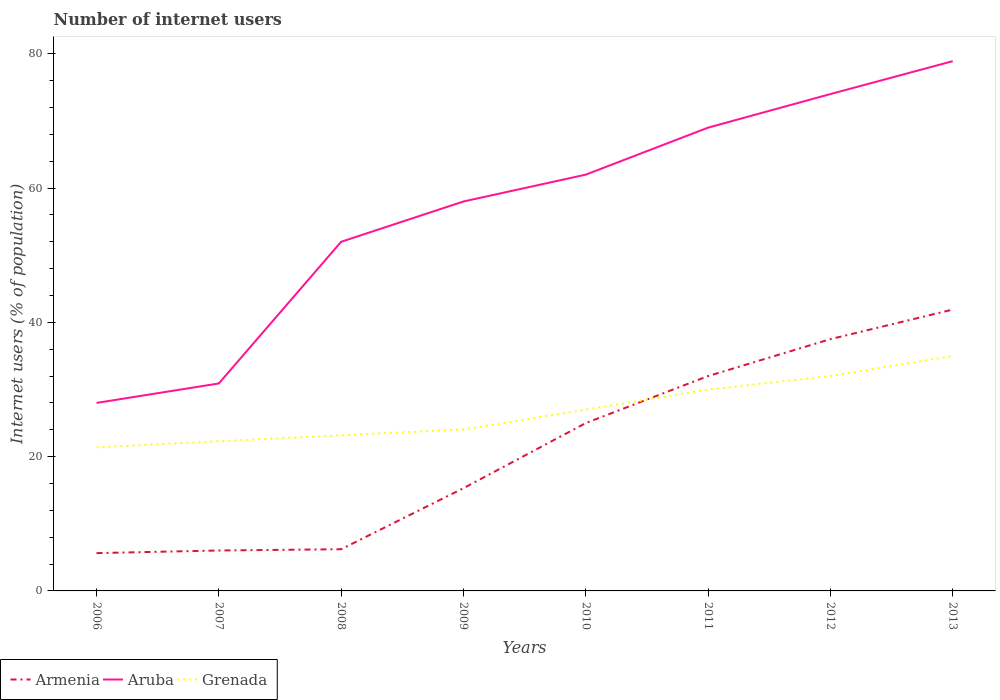Does the line corresponding to Aruba intersect with the line corresponding to Armenia?
Your answer should be very brief. No. Across all years, what is the maximum number of internet users in Grenada?
Provide a short and direct response. 21.4. In which year was the number of internet users in Armenia maximum?
Your response must be concise. 2006. What is the total number of internet users in Aruba in the graph?
Keep it short and to the point. -34. What is the difference between the highest and the second highest number of internet users in Aruba?
Offer a terse response. 50.9. Is the number of internet users in Grenada strictly greater than the number of internet users in Armenia over the years?
Your response must be concise. No. What is the difference between two consecutive major ticks on the Y-axis?
Your answer should be compact. 20. Does the graph contain any zero values?
Your answer should be compact. No. Does the graph contain grids?
Provide a succinct answer. No. How are the legend labels stacked?
Your response must be concise. Horizontal. What is the title of the graph?
Provide a short and direct response. Number of internet users. What is the label or title of the Y-axis?
Offer a terse response. Internet users (% of population). What is the Internet users (% of population) of Armenia in 2006?
Offer a very short reply. 5.63. What is the Internet users (% of population) in Grenada in 2006?
Provide a succinct answer. 21.4. What is the Internet users (% of population) of Armenia in 2007?
Ensure brevity in your answer.  6.02. What is the Internet users (% of population) in Aruba in 2007?
Offer a terse response. 30.9. What is the Internet users (% of population) in Grenada in 2007?
Keep it short and to the point. 22.29. What is the Internet users (% of population) of Armenia in 2008?
Give a very brief answer. 6.21. What is the Internet users (% of population) of Aruba in 2008?
Keep it short and to the point. 52. What is the Internet users (% of population) of Grenada in 2008?
Your answer should be compact. 23.18. What is the Internet users (% of population) of Aruba in 2009?
Ensure brevity in your answer.  58. What is the Internet users (% of population) of Grenada in 2009?
Offer a very short reply. 24.05. What is the Internet users (% of population) in Armenia in 2010?
Provide a short and direct response. 25. What is the Internet users (% of population) of Grenada in 2011?
Offer a terse response. 30. What is the Internet users (% of population) of Armenia in 2012?
Your answer should be compact. 37.5. What is the Internet users (% of population) of Aruba in 2012?
Make the answer very short. 74. What is the Internet users (% of population) in Grenada in 2012?
Provide a short and direct response. 32. What is the Internet users (% of population) in Armenia in 2013?
Provide a succinct answer. 41.9. What is the Internet users (% of population) of Aruba in 2013?
Ensure brevity in your answer.  78.9. What is the Internet users (% of population) in Grenada in 2013?
Make the answer very short. 35. Across all years, what is the maximum Internet users (% of population) in Armenia?
Provide a short and direct response. 41.9. Across all years, what is the maximum Internet users (% of population) in Aruba?
Make the answer very short. 78.9. Across all years, what is the maximum Internet users (% of population) in Grenada?
Your answer should be compact. 35. Across all years, what is the minimum Internet users (% of population) of Armenia?
Ensure brevity in your answer.  5.63. Across all years, what is the minimum Internet users (% of population) in Aruba?
Make the answer very short. 28. Across all years, what is the minimum Internet users (% of population) of Grenada?
Offer a terse response. 21.4. What is the total Internet users (% of population) in Armenia in the graph?
Provide a short and direct response. 169.56. What is the total Internet users (% of population) in Aruba in the graph?
Keep it short and to the point. 452.8. What is the total Internet users (% of population) of Grenada in the graph?
Your answer should be very brief. 214.92. What is the difference between the Internet users (% of population) in Armenia in 2006 and that in 2007?
Your response must be concise. -0.39. What is the difference between the Internet users (% of population) in Grenada in 2006 and that in 2007?
Give a very brief answer. -0.89. What is the difference between the Internet users (% of population) in Armenia in 2006 and that in 2008?
Offer a very short reply. -0.58. What is the difference between the Internet users (% of population) of Aruba in 2006 and that in 2008?
Give a very brief answer. -24. What is the difference between the Internet users (% of population) of Grenada in 2006 and that in 2008?
Give a very brief answer. -1.78. What is the difference between the Internet users (% of population) of Armenia in 2006 and that in 2009?
Your response must be concise. -9.67. What is the difference between the Internet users (% of population) of Grenada in 2006 and that in 2009?
Give a very brief answer. -2.65. What is the difference between the Internet users (% of population) of Armenia in 2006 and that in 2010?
Your response must be concise. -19.37. What is the difference between the Internet users (% of population) in Aruba in 2006 and that in 2010?
Ensure brevity in your answer.  -34. What is the difference between the Internet users (% of population) in Grenada in 2006 and that in 2010?
Your response must be concise. -5.6. What is the difference between the Internet users (% of population) in Armenia in 2006 and that in 2011?
Make the answer very short. -26.37. What is the difference between the Internet users (% of population) in Aruba in 2006 and that in 2011?
Ensure brevity in your answer.  -41. What is the difference between the Internet users (% of population) in Grenada in 2006 and that in 2011?
Offer a very short reply. -8.6. What is the difference between the Internet users (% of population) in Armenia in 2006 and that in 2012?
Give a very brief answer. -31.87. What is the difference between the Internet users (% of population) in Aruba in 2006 and that in 2012?
Your answer should be very brief. -46. What is the difference between the Internet users (% of population) of Grenada in 2006 and that in 2012?
Keep it short and to the point. -10.6. What is the difference between the Internet users (% of population) of Armenia in 2006 and that in 2013?
Offer a terse response. -36.27. What is the difference between the Internet users (% of population) of Aruba in 2006 and that in 2013?
Your answer should be compact. -50.9. What is the difference between the Internet users (% of population) in Grenada in 2006 and that in 2013?
Keep it short and to the point. -13.6. What is the difference between the Internet users (% of population) of Armenia in 2007 and that in 2008?
Keep it short and to the point. -0.19. What is the difference between the Internet users (% of population) in Aruba in 2007 and that in 2008?
Provide a short and direct response. -21.1. What is the difference between the Internet users (% of population) in Grenada in 2007 and that in 2008?
Give a very brief answer. -0.89. What is the difference between the Internet users (% of population) in Armenia in 2007 and that in 2009?
Your answer should be very brief. -9.28. What is the difference between the Internet users (% of population) of Aruba in 2007 and that in 2009?
Provide a short and direct response. -27.1. What is the difference between the Internet users (% of population) in Grenada in 2007 and that in 2009?
Give a very brief answer. -1.76. What is the difference between the Internet users (% of population) in Armenia in 2007 and that in 2010?
Your answer should be very brief. -18.98. What is the difference between the Internet users (% of population) of Aruba in 2007 and that in 2010?
Offer a terse response. -31.1. What is the difference between the Internet users (% of population) in Grenada in 2007 and that in 2010?
Your answer should be compact. -4.71. What is the difference between the Internet users (% of population) in Armenia in 2007 and that in 2011?
Your answer should be compact. -25.98. What is the difference between the Internet users (% of population) of Aruba in 2007 and that in 2011?
Provide a succinct answer. -38.1. What is the difference between the Internet users (% of population) of Grenada in 2007 and that in 2011?
Ensure brevity in your answer.  -7.71. What is the difference between the Internet users (% of population) of Armenia in 2007 and that in 2012?
Make the answer very short. -31.48. What is the difference between the Internet users (% of population) in Aruba in 2007 and that in 2012?
Provide a short and direct response. -43.1. What is the difference between the Internet users (% of population) of Grenada in 2007 and that in 2012?
Keep it short and to the point. -9.71. What is the difference between the Internet users (% of population) of Armenia in 2007 and that in 2013?
Offer a terse response. -35.88. What is the difference between the Internet users (% of population) in Aruba in 2007 and that in 2013?
Offer a terse response. -48. What is the difference between the Internet users (% of population) in Grenada in 2007 and that in 2013?
Keep it short and to the point. -12.71. What is the difference between the Internet users (% of population) in Armenia in 2008 and that in 2009?
Your answer should be very brief. -9.09. What is the difference between the Internet users (% of population) in Aruba in 2008 and that in 2009?
Provide a succinct answer. -6. What is the difference between the Internet users (% of population) in Grenada in 2008 and that in 2009?
Your response must be concise. -0.87. What is the difference between the Internet users (% of population) of Armenia in 2008 and that in 2010?
Your answer should be very brief. -18.79. What is the difference between the Internet users (% of population) of Grenada in 2008 and that in 2010?
Keep it short and to the point. -3.82. What is the difference between the Internet users (% of population) in Armenia in 2008 and that in 2011?
Your answer should be very brief. -25.79. What is the difference between the Internet users (% of population) in Aruba in 2008 and that in 2011?
Offer a very short reply. -17. What is the difference between the Internet users (% of population) in Grenada in 2008 and that in 2011?
Provide a short and direct response. -6.82. What is the difference between the Internet users (% of population) of Armenia in 2008 and that in 2012?
Make the answer very short. -31.29. What is the difference between the Internet users (% of population) in Grenada in 2008 and that in 2012?
Your answer should be compact. -8.82. What is the difference between the Internet users (% of population) of Armenia in 2008 and that in 2013?
Your response must be concise. -35.69. What is the difference between the Internet users (% of population) in Aruba in 2008 and that in 2013?
Offer a terse response. -26.9. What is the difference between the Internet users (% of population) of Grenada in 2008 and that in 2013?
Offer a very short reply. -11.82. What is the difference between the Internet users (% of population) in Armenia in 2009 and that in 2010?
Offer a very short reply. -9.7. What is the difference between the Internet users (% of population) in Aruba in 2009 and that in 2010?
Offer a terse response. -4. What is the difference between the Internet users (% of population) in Grenada in 2009 and that in 2010?
Give a very brief answer. -2.95. What is the difference between the Internet users (% of population) of Armenia in 2009 and that in 2011?
Make the answer very short. -16.7. What is the difference between the Internet users (% of population) of Aruba in 2009 and that in 2011?
Your answer should be compact. -11. What is the difference between the Internet users (% of population) of Grenada in 2009 and that in 2011?
Provide a short and direct response. -5.95. What is the difference between the Internet users (% of population) in Armenia in 2009 and that in 2012?
Offer a terse response. -22.2. What is the difference between the Internet users (% of population) of Grenada in 2009 and that in 2012?
Give a very brief answer. -7.95. What is the difference between the Internet users (% of population) in Armenia in 2009 and that in 2013?
Provide a succinct answer. -26.6. What is the difference between the Internet users (% of population) of Aruba in 2009 and that in 2013?
Ensure brevity in your answer.  -20.9. What is the difference between the Internet users (% of population) in Grenada in 2009 and that in 2013?
Your response must be concise. -10.95. What is the difference between the Internet users (% of population) of Armenia in 2010 and that in 2011?
Provide a short and direct response. -7. What is the difference between the Internet users (% of population) of Aruba in 2010 and that in 2011?
Your answer should be compact. -7. What is the difference between the Internet users (% of population) in Armenia in 2010 and that in 2012?
Provide a short and direct response. -12.5. What is the difference between the Internet users (% of population) in Aruba in 2010 and that in 2012?
Give a very brief answer. -12. What is the difference between the Internet users (% of population) of Armenia in 2010 and that in 2013?
Give a very brief answer. -16.9. What is the difference between the Internet users (% of population) of Aruba in 2010 and that in 2013?
Offer a very short reply. -16.9. What is the difference between the Internet users (% of population) of Aruba in 2011 and that in 2012?
Ensure brevity in your answer.  -5. What is the difference between the Internet users (% of population) of Armenia in 2011 and that in 2013?
Provide a succinct answer. -9.9. What is the difference between the Internet users (% of population) in Grenada in 2011 and that in 2013?
Offer a very short reply. -5. What is the difference between the Internet users (% of population) of Armenia in 2012 and that in 2013?
Provide a succinct answer. -4.4. What is the difference between the Internet users (% of population) of Aruba in 2012 and that in 2013?
Provide a short and direct response. -4.9. What is the difference between the Internet users (% of population) in Grenada in 2012 and that in 2013?
Your response must be concise. -3. What is the difference between the Internet users (% of population) in Armenia in 2006 and the Internet users (% of population) in Aruba in 2007?
Ensure brevity in your answer.  -25.27. What is the difference between the Internet users (% of population) in Armenia in 2006 and the Internet users (% of population) in Grenada in 2007?
Provide a short and direct response. -16.66. What is the difference between the Internet users (% of population) in Aruba in 2006 and the Internet users (% of population) in Grenada in 2007?
Ensure brevity in your answer.  5.71. What is the difference between the Internet users (% of population) in Armenia in 2006 and the Internet users (% of population) in Aruba in 2008?
Offer a very short reply. -46.37. What is the difference between the Internet users (% of population) of Armenia in 2006 and the Internet users (% of population) of Grenada in 2008?
Ensure brevity in your answer.  -17.55. What is the difference between the Internet users (% of population) in Aruba in 2006 and the Internet users (% of population) in Grenada in 2008?
Give a very brief answer. 4.82. What is the difference between the Internet users (% of population) of Armenia in 2006 and the Internet users (% of population) of Aruba in 2009?
Ensure brevity in your answer.  -52.37. What is the difference between the Internet users (% of population) in Armenia in 2006 and the Internet users (% of population) in Grenada in 2009?
Provide a succinct answer. -18.42. What is the difference between the Internet users (% of population) in Aruba in 2006 and the Internet users (% of population) in Grenada in 2009?
Your response must be concise. 3.95. What is the difference between the Internet users (% of population) of Armenia in 2006 and the Internet users (% of population) of Aruba in 2010?
Give a very brief answer. -56.37. What is the difference between the Internet users (% of population) of Armenia in 2006 and the Internet users (% of population) of Grenada in 2010?
Provide a succinct answer. -21.37. What is the difference between the Internet users (% of population) in Armenia in 2006 and the Internet users (% of population) in Aruba in 2011?
Your answer should be compact. -63.37. What is the difference between the Internet users (% of population) of Armenia in 2006 and the Internet users (% of population) of Grenada in 2011?
Your response must be concise. -24.37. What is the difference between the Internet users (% of population) in Aruba in 2006 and the Internet users (% of population) in Grenada in 2011?
Your answer should be very brief. -2. What is the difference between the Internet users (% of population) of Armenia in 2006 and the Internet users (% of population) of Aruba in 2012?
Make the answer very short. -68.37. What is the difference between the Internet users (% of population) in Armenia in 2006 and the Internet users (% of population) in Grenada in 2012?
Your response must be concise. -26.37. What is the difference between the Internet users (% of population) in Aruba in 2006 and the Internet users (% of population) in Grenada in 2012?
Ensure brevity in your answer.  -4. What is the difference between the Internet users (% of population) of Armenia in 2006 and the Internet users (% of population) of Aruba in 2013?
Provide a succinct answer. -73.27. What is the difference between the Internet users (% of population) in Armenia in 2006 and the Internet users (% of population) in Grenada in 2013?
Your answer should be very brief. -29.37. What is the difference between the Internet users (% of population) in Armenia in 2007 and the Internet users (% of population) in Aruba in 2008?
Offer a very short reply. -45.98. What is the difference between the Internet users (% of population) of Armenia in 2007 and the Internet users (% of population) of Grenada in 2008?
Keep it short and to the point. -17.16. What is the difference between the Internet users (% of population) in Aruba in 2007 and the Internet users (% of population) in Grenada in 2008?
Your response must be concise. 7.72. What is the difference between the Internet users (% of population) in Armenia in 2007 and the Internet users (% of population) in Aruba in 2009?
Offer a terse response. -51.98. What is the difference between the Internet users (% of population) of Armenia in 2007 and the Internet users (% of population) of Grenada in 2009?
Keep it short and to the point. -18.03. What is the difference between the Internet users (% of population) in Aruba in 2007 and the Internet users (% of population) in Grenada in 2009?
Offer a terse response. 6.85. What is the difference between the Internet users (% of population) of Armenia in 2007 and the Internet users (% of population) of Aruba in 2010?
Give a very brief answer. -55.98. What is the difference between the Internet users (% of population) of Armenia in 2007 and the Internet users (% of population) of Grenada in 2010?
Make the answer very short. -20.98. What is the difference between the Internet users (% of population) in Armenia in 2007 and the Internet users (% of population) in Aruba in 2011?
Provide a short and direct response. -62.98. What is the difference between the Internet users (% of population) of Armenia in 2007 and the Internet users (% of population) of Grenada in 2011?
Provide a succinct answer. -23.98. What is the difference between the Internet users (% of population) of Aruba in 2007 and the Internet users (% of population) of Grenada in 2011?
Provide a short and direct response. 0.9. What is the difference between the Internet users (% of population) in Armenia in 2007 and the Internet users (% of population) in Aruba in 2012?
Your answer should be compact. -67.98. What is the difference between the Internet users (% of population) in Armenia in 2007 and the Internet users (% of population) in Grenada in 2012?
Keep it short and to the point. -25.98. What is the difference between the Internet users (% of population) of Armenia in 2007 and the Internet users (% of population) of Aruba in 2013?
Your response must be concise. -72.88. What is the difference between the Internet users (% of population) of Armenia in 2007 and the Internet users (% of population) of Grenada in 2013?
Make the answer very short. -28.98. What is the difference between the Internet users (% of population) of Armenia in 2008 and the Internet users (% of population) of Aruba in 2009?
Ensure brevity in your answer.  -51.79. What is the difference between the Internet users (% of population) in Armenia in 2008 and the Internet users (% of population) in Grenada in 2009?
Make the answer very short. -17.84. What is the difference between the Internet users (% of population) of Aruba in 2008 and the Internet users (% of population) of Grenada in 2009?
Provide a succinct answer. 27.95. What is the difference between the Internet users (% of population) of Armenia in 2008 and the Internet users (% of population) of Aruba in 2010?
Provide a succinct answer. -55.79. What is the difference between the Internet users (% of population) in Armenia in 2008 and the Internet users (% of population) in Grenada in 2010?
Provide a succinct answer. -20.79. What is the difference between the Internet users (% of population) in Armenia in 2008 and the Internet users (% of population) in Aruba in 2011?
Your response must be concise. -62.79. What is the difference between the Internet users (% of population) in Armenia in 2008 and the Internet users (% of population) in Grenada in 2011?
Your answer should be compact. -23.79. What is the difference between the Internet users (% of population) of Aruba in 2008 and the Internet users (% of population) of Grenada in 2011?
Make the answer very short. 22. What is the difference between the Internet users (% of population) in Armenia in 2008 and the Internet users (% of population) in Aruba in 2012?
Your answer should be very brief. -67.79. What is the difference between the Internet users (% of population) in Armenia in 2008 and the Internet users (% of population) in Grenada in 2012?
Make the answer very short. -25.79. What is the difference between the Internet users (% of population) of Aruba in 2008 and the Internet users (% of population) of Grenada in 2012?
Your response must be concise. 20. What is the difference between the Internet users (% of population) in Armenia in 2008 and the Internet users (% of population) in Aruba in 2013?
Give a very brief answer. -72.69. What is the difference between the Internet users (% of population) in Armenia in 2008 and the Internet users (% of population) in Grenada in 2013?
Make the answer very short. -28.79. What is the difference between the Internet users (% of population) in Aruba in 2008 and the Internet users (% of population) in Grenada in 2013?
Provide a succinct answer. 17. What is the difference between the Internet users (% of population) in Armenia in 2009 and the Internet users (% of population) in Aruba in 2010?
Your response must be concise. -46.7. What is the difference between the Internet users (% of population) of Armenia in 2009 and the Internet users (% of population) of Aruba in 2011?
Your answer should be compact. -53.7. What is the difference between the Internet users (% of population) in Armenia in 2009 and the Internet users (% of population) in Grenada in 2011?
Offer a terse response. -14.7. What is the difference between the Internet users (% of population) in Aruba in 2009 and the Internet users (% of population) in Grenada in 2011?
Your response must be concise. 28. What is the difference between the Internet users (% of population) of Armenia in 2009 and the Internet users (% of population) of Aruba in 2012?
Provide a short and direct response. -58.7. What is the difference between the Internet users (% of population) in Armenia in 2009 and the Internet users (% of population) in Grenada in 2012?
Offer a terse response. -16.7. What is the difference between the Internet users (% of population) of Aruba in 2009 and the Internet users (% of population) of Grenada in 2012?
Give a very brief answer. 26. What is the difference between the Internet users (% of population) in Armenia in 2009 and the Internet users (% of population) in Aruba in 2013?
Keep it short and to the point. -63.6. What is the difference between the Internet users (% of population) in Armenia in 2009 and the Internet users (% of population) in Grenada in 2013?
Your answer should be very brief. -19.7. What is the difference between the Internet users (% of population) in Armenia in 2010 and the Internet users (% of population) in Aruba in 2011?
Give a very brief answer. -44. What is the difference between the Internet users (% of population) of Armenia in 2010 and the Internet users (% of population) of Grenada in 2011?
Keep it short and to the point. -5. What is the difference between the Internet users (% of population) of Aruba in 2010 and the Internet users (% of population) of Grenada in 2011?
Provide a succinct answer. 32. What is the difference between the Internet users (% of population) of Armenia in 2010 and the Internet users (% of population) of Aruba in 2012?
Offer a very short reply. -49. What is the difference between the Internet users (% of population) of Armenia in 2010 and the Internet users (% of population) of Grenada in 2012?
Make the answer very short. -7. What is the difference between the Internet users (% of population) in Aruba in 2010 and the Internet users (% of population) in Grenada in 2012?
Your answer should be compact. 30. What is the difference between the Internet users (% of population) in Armenia in 2010 and the Internet users (% of population) in Aruba in 2013?
Offer a terse response. -53.9. What is the difference between the Internet users (% of population) in Armenia in 2011 and the Internet users (% of population) in Aruba in 2012?
Ensure brevity in your answer.  -42. What is the difference between the Internet users (% of population) in Aruba in 2011 and the Internet users (% of population) in Grenada in 2012?
Offer a very short reply. 37. What is the difference between the Internet users (% of population) of Armenia in 2011 and the Internet users (% of population) of Aruba in 2013?
Your answer should be very brief. -46.9. What is the difference between the Internet users (% of population) of Armenia in 2012 and the Internet users (% of population) of Aruba in 2013?
Provide a short and direct response. -41.4. What is the average Internet users (% of population) of Armenia per year?
Offer a terse response. 21.2. What is the average Internet users (% of population) of Aruba per year?
Provide a short and direct response. 56.6. What is the average Internet users (% of population) of Grenada per year?
Provide a succinct answer. 26.86. In the year 2006, what is the difference between the Internet users (% of population) in Armenia and Internet users (% of population) in Aruba?
Keep it short and to the point. -22.37. In the year 2006, what is the difference between the Internet users (% of population) of Armenia and Internet users (% of population) of Grenada?
Make the answer very short. -15.76. In the year 2006, what is the difference between the Internet users (% of population) in Aruba and Internet users (% of population) in Grenada?
Ensure brevity in your answer.  6.6. In the year 2007, what is the difference between the Internet users (% of population) of Armenia and Internet users (% of population) of Aruba?
Offer a terse response. -24.88. In the year 2007, what is the difference between the Internet users (% of population) of Armenia and Internet users (% of population) of Grenada?
Ensure brevity in your answer.  -16.27. In the year 2007, what is the difference between the Internet users (% of population) of Aruba and Internet users (% of population) of Grenada?
Make the answer very short. 8.61. In the year 2008, what is the difference between the Internet users (% of population) in Armenia and Internet users (% of population) in Aruba?
Ensure brevity in your answer.  -45.79. In the year 2008, what is the difference between the Internet users (% of population) of Armenia and Internet users (% of population) of Grenada?
Ensure brevity in your answer.  -16.97. In the year 2008, what is the difference between the Internet users (% of population) of Aruba and Internet users (% of population) of Grenada?
Keep it short and to the point. 28.82. In the year 2009, what is the difference between the Internet users (% of population) of Armenia and Internet users (% of population) of Aruba?
Your answer should be very brief. -42.7. In the year 2009, what is the difference between the Internet users (% of population) in Armenia and Internet users (% of population) in Grenada?
Offer a very short reply. -8.75. In the year 2009, what is the difference between the Internet users (% of population) of Aruba and Internet users (% of population) of Grenada?
Offer a very short reply. 33.95. In the year 2010, what is the difference between the Internet users (% of population) in Armenia and Internet users (% of population) in Aruba?
Make the answer very short. -37. In the year 2010, what is the difference between the Internet users (% of population) in Aruba and Internet users (% of population) in Grenada?
Ensure brevity in your answer.  35. In the year 2011, what is the difference between the Internet users (% of population) of Armenia and Internet users (% of population) of Aruba?
Your answer should be very brief. -37. In the year 2011, what is the difference between the Internet users (% of population) of Armenia and Internet users (% of population) of Grenada?
Your answer should be compact. 2. In the year 2012, what is the difference between the Internet users (% of population) of Armenia and Internet users (% of population) of Aruba?
Your answer should be compact. -36.5. In the year 2012, what is the difference between the Internet users (% of population) of Armenia and Internet users (% of population) of Grenada?
Your response must be concise. 5.5. In the year 2013, what is the difference between the Internet users (% of population) of Armenia and Internet users (% of population) of Aruba?
Your answer should be compact. -37. In the year 2013, what is the difference between the Internet users (% of population) of Armenia and Internet users (% of population) of Grenada?
Your answer should be very brief. 6.9. In the year 2013, what is the difference between the Internet users (% of population) of Aruba and Internet users (% of population) of Grenada?
Make the answer very short. 43.9. What is the ratio of the Internet users (% of population) in Armenia in 2006 to that in 2007?
Your answer should be compact. 0.94. What is the ratio of the Internet users (% of population) in Aruba in 2006 to that in 2007?
Give a very brief answer. 0.91. What is the ratio of the Internet users (% of population) of Grenada in 2006 to that in 2007?
Offer a very short reply. 0.96. What is the ratio of the Internet users (% of population) in Armenia in 2006 to that in 2008?
Offer a very short reply. 0.91. What is the ratio of the Internet users (% of population) in Aruba in 2006 to that in 2008?
Provide a short and direct response. 0.54. What is the ratio of the Internet users (% of population) in Grenada in 2006 to that in 2008?
Offer a terse response. 0.92. What is the ratio of the Internet users (% of population) of Armenia in 2006 to that in 2009?
Your answer should be very brief. 0.37. What is the ratio of the Internet users (% of population) in Aruba in 2006 to that in 2009?
Your answer should be compact. 0.48. What is the ratio of the Internet users (% of population) of Grenada in 2006 to that in 2009?
Offer a terse response. 0.89. What is the ratio of the Internet users (% of population) of Armenia in 2006 to that in 2010?
Give a very brief answer. 0.23. What is the ratio of the Internet users (% of population) in Aruba in 2006 to that in 2010?
Keep it short and to the point. 0.45. What is the ratio of the Internet users (% of population) in Grenada in 2006 to that in 2010?
Offer a terse response. 0.79. What is the ratio of the Internet users (% of population) in Armenia in 2006 to that in 2011?
Your answer should be very brief. 0.18. What is the ratio of the Internet users (% of population) in Aruba in 2006 to that in 2011?
Provide a succinct answer. 0.41. What is the ratio of the Internet users (% of population) of Grenada in 2006 to that in 2011?
Provide a short and direct response. 0.71. What is the ratio of the Internet users (% of population) of Armenia in 2006 to that in 2012?
Offer a very short reply. 0.15. What is the ratio of the Internet users (% of population) of Aruba in 2006 to that in 2012?
Make the answer very short. 0.38. What is the ratio of the Internet users (% of population) in Grenada in 2006 to that in 2012?
Your answer should be compact. 0.67. What is the ratio of the Internet users (% of population) of Armenia in 2006 to that in 2013?
Offer a terse response. 0.13. What is the ratio of the Internet users (% of population) in Aruba in 2006 to that in 2013?
Offer a terse response. 0.35. What is the ratio of the Internet users (% of population) of Grenada in 2006 to that in 2013?
Your answer should be very brief. 0.61. What is the ratio of the Internet users (% of population) in Armenia in 2007 to that in 2008?
Your response must be concise. 0.97. What is the ratio of the Internet users (% of population) in Aruba in 2007 to that in 2008?
Your answer should be very brief. 0.59. What is the ratio of the Internet users (% of population) of Grenada in 2007 to that in 2008?
Your answer should be compact. 0.96. What is the ratio of the Internet users (% of population) in Armenia in 2007 to that in 2009?
Offer a very short reply. 0.39. What is the ratio of the Internet users (% of population) in Aruba in 2007 to that in 2009?
Ensure brevity in your answer.  0.53. What is the ratio of the Internet users (% of population) in Grenada in 2007 to that in 2009?
Your answer should be very brief. 0.93. What is the ratio of the Internet users (% of population) of Armenia in 2007 to that in 2010?
Offer a very short reply. 0.24. What is the ratio of the Internet users (% of population) in Aruba in 2007 to that in 2010?
Provide a succinct answer. 0.5. What is the ratio of the Internet users (% of population) in Grenada in 2007 to that in 2010?
Keep it short and to the point. 0.83. What is the ratio of the Internet users (% of population) of Armenia in 2007 to that in 2011?
Offer a terse response. 0.19. What is the ratio of the Internet users (% of population) in Aruba in 2007 to that in 2011?
Keep it short and to the point. 0.45. What is the ratio of the Internet users (% of population) in Grenada in 2007 to that in 2011?
Offer a terse response. 0.74. What is the ratio of the Internet users (% of population) of Armenia in 2007 to that in 2012?
Make the answer very short. 0.16. What is the ratio of the Internet users (% of population) of Aruba in 2007 to that in 2012?
Ensure brevity in your answer.  0.42. What is the ratio of the Internet users (% of population) of Grenada in 2007 to that in 2012?
Your response must be concise. 0.7. What is the ratio of the Internet users (% of population) of Armenia in 2007 to that in 2013?
Make the answer very short. 0.14. What is the ratio of the Internet users (% of population) of Aruba in 2007 to that in 2013?
Give a very brief answer. 0.39. What is the ratio of the Internet users (% of population) in Grenada in 2007 to that in 2013?
Your answer should be very brief. 0.64. What is the ratio of the Internet users (% of population) of Armenia in 2008 to that in 2009?
Make the answer very short. 0.41. What is the ratio of the Internet users (% of population) in Aruba in 2008 to that in 2009?
Give a very brief answer. 0.9. What is the ratio of the Internet users (% of population) in Grenada in 2008 to that in 2009?
Your answer should be compact. 0.96. What is the ratio of the Internet users (% of population) in Armenia in 2008 to that in 2010?
Ensure brevity in your answer.  0.25. What is the ratio of the Internet users (% of population) of Aruba in 2008 to that in 2010?
Your answer should be very brief. 0.84. What is the ratio of the Internet users (% of population) of Grenada in 2008 to that in 2010?
Provide a short and direct response. 0.86. What is the ratio of the Internet users (% of population) of Armenia in 2008 to that in 2011?
Your answer should be compact. 0.19. What is the ratio of the Internet users (% of population) of Aruba in 2008 to that in 2011?
Your answer should be very brief. 0.75. What is the ratio of the Internet users (% of population) of Grenada in 2008 to that in 2011?
Ensure brevity in your answer.  0.77. What is the ratio of the Internet users (% of population) in Armenia in 2008 to that in 2012?
Keep it short and to the point. 0.17. What is the ratio of the Internet users (% of population) in Aruba in 2008 to that in 2012?
Ensure brevity in your answer.  0.7. What is the ratio of the Internet users (% of population) in Grenada in 2008 to that in 2012?
Your response must be concise. 0.72. What is the ratio of the Internet users (% of population) of Armenia in 2008 to that in 2013?
Provide a short and direct response. 0.15. What is the ratio of the Internet users (% of population) in Aruba in 2008 to that in 2013?
Give a very brief answer. 0.66. What is the ratio of the Internet users (% of population) of Grenada in 2008 to that in 2013?
Provide a succinct answer. 0.66. What is the ratio of the Internet users (% of population) in Armenia in 2009 to that in 2010?
Provide a short and direct response. 0.61. What is the ratio of the Internet users (% of population) of Aruba in 2009 to that in 2010?
Your answer should be very brief. 0.94. What is the ratio of the Internet users (% of population) of Grenada in 2009 to that in 2010?
Your response must be concise. 0.89. What is the ratio of the Internet users (% of population) of Armenia in 2009 to that in 2011?
Offer a very short reply. 0.48. What is the ratio of the Internet users (% of population) in Aruba in 2009 to that in 2011?
Provide a succinct answer. 0.84. What is the ratio of the Internet users (% of population) in Grenada in 2009 to that in 2011?
Ensure brevity in your answer.  0.8. What is the ratio of the Internet users (% of population) of Armenia in 2009 to that in 2012?
Make the answer very short. 0.41. What is the ratio of the Internet users (% of population) of Aruba in 2009 to that in 2012?
Give a very brief answer. 0.78. What is the ratio of the Internet users (% of population) in Grenada in 2009 to that in 2012?
Your response must be concise. 0.75. What is the ratio of the Internet users (% of population) of Armenia in 2009 to that in 2013?
Keep it short and to the point. 0.37. What is the ratio of the Internet users (% of population) of Aruba in 2009 to that in 2013?
Make the answer very short. 0.74. What is the ratio of the Internet users (% of population) in Grenada in 2009 to that in 2013?
Offer a terse response. 0.69. What is the ratio of the Internet users (% of population) in Armenia in 2010 to that in 2011?
Offer a terse response. 0.78. What is the ratio of the Internet users (% of population) in Aruba in 2010 to that in 2011?
Offer a terse response. 0.9. What is the ratio of the Internet users (% of population) in Grenada in 2010 to that in 2011?
Your answer should be compact. 0.9. What is the ratio of the Internet users (% of population) in Armenia in 2010 to that in 2012?
Your answer should be compact. 0.67. What is the ratio of the Internet users (% of population) of Aruba in 2010 to that in 2012?
Make the answer very short. 0.84. What is the ratio of the Internet users (% of population) of Grenada in 2010 to that in 2012?
Provide a short and direct response. 0.84. What is the ratio of the Internet users (% of population) in Armenia in 2010 to that in 2013?
Give a very brief answer. 0.6. What is the ratio of the Internet users (% of population) in Aruba in 2010 to that in 2013?
Offer a terse response. 0.79. What is the ratio of the Internet users (% of population) in Grenada in 2010 to that in 2013?
Provide a succinct answer. 0.77. What is the ratio of the Internet users (% of population) of Armenia in 2011 to that in 2012?
Offer a terse response. 0.85. What is the ratio of the Internet users (% of population) of Aruba in 2011 to that in 2012?
Make the answer very short. 0.93. What is the ratio of the Internet users (% of population) of Armenia in 2011 to that in 2013?
Your answer should be very brief. 0.76. What is the ratio of the Internet users (% of population) in Aruba in 2011 to that in 2013?
Ensure brevity in your answer.  0.87. What is the ratio of the Internet users (% of population) of Armenia in 2012 to that in 2013?
Your answer should be compact. 0.9. What is the ratio of the Internet users (% of population) in Aruba in 2012 to that in 2013?
Give a very brief answer. 0.94. What is the ratio of the Internet users (% of population) in Grenada in 2012 to that in 2013?
Ensure brevity in your answer.  0.91. What is the difference between the highest and the second highest Internet users (% of population) of Armenia?
Give a very brief answer. 4.4. What is the difference between the highest and the second highest Internet users (% of population) of Aruba?
Your answer should be compact. 4.9. What is the difference between the highest and the lowest Internet users (% of population) of Armenia?
Your answer should be compact. 36.27. What is the difference between the highest and the lowest Internet users (% of population) of Aruba?
Provide a short and direct response. 50.9. What is the difference between the highest and the lowest Internet users (% of population) of Grenada?
Offer a terse response. 13.6. 